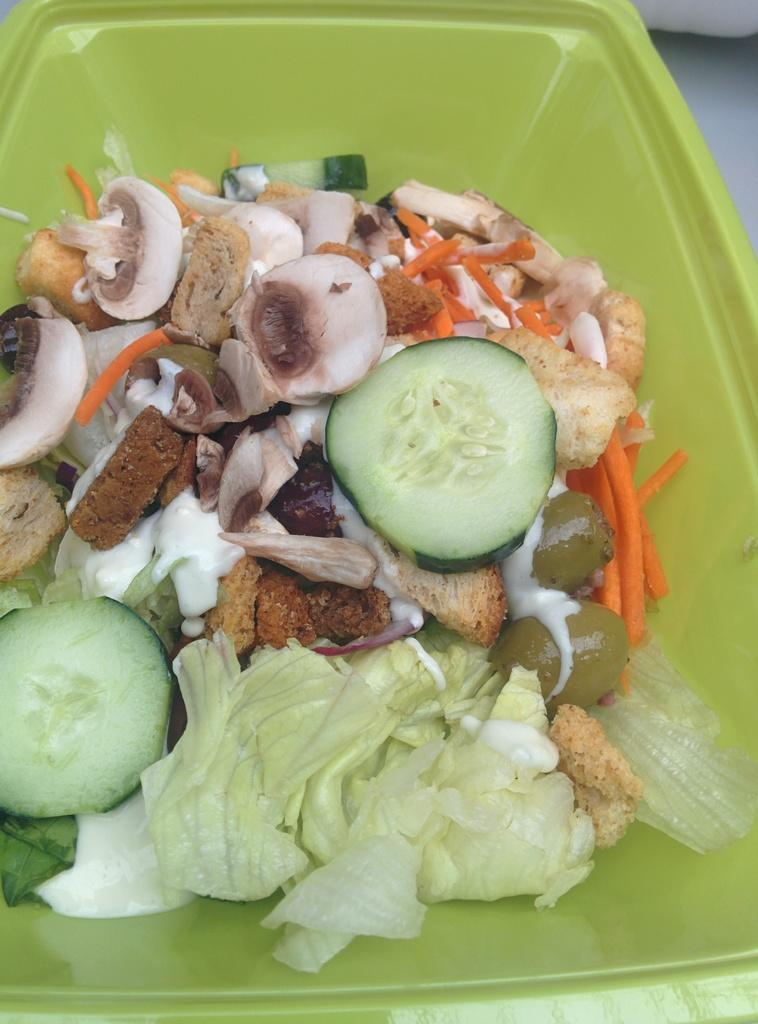What is inside the box that is visible in the image? There is a box containing salad in the image. What specific ingredients are included in the salad? The salad includes cucumber, carrots, cabbage, and mushrooms. What type of structure can be seen in the background of the image? There is no structure visible in the background of the image; it only shows a box containing salad with specific ingredients. 